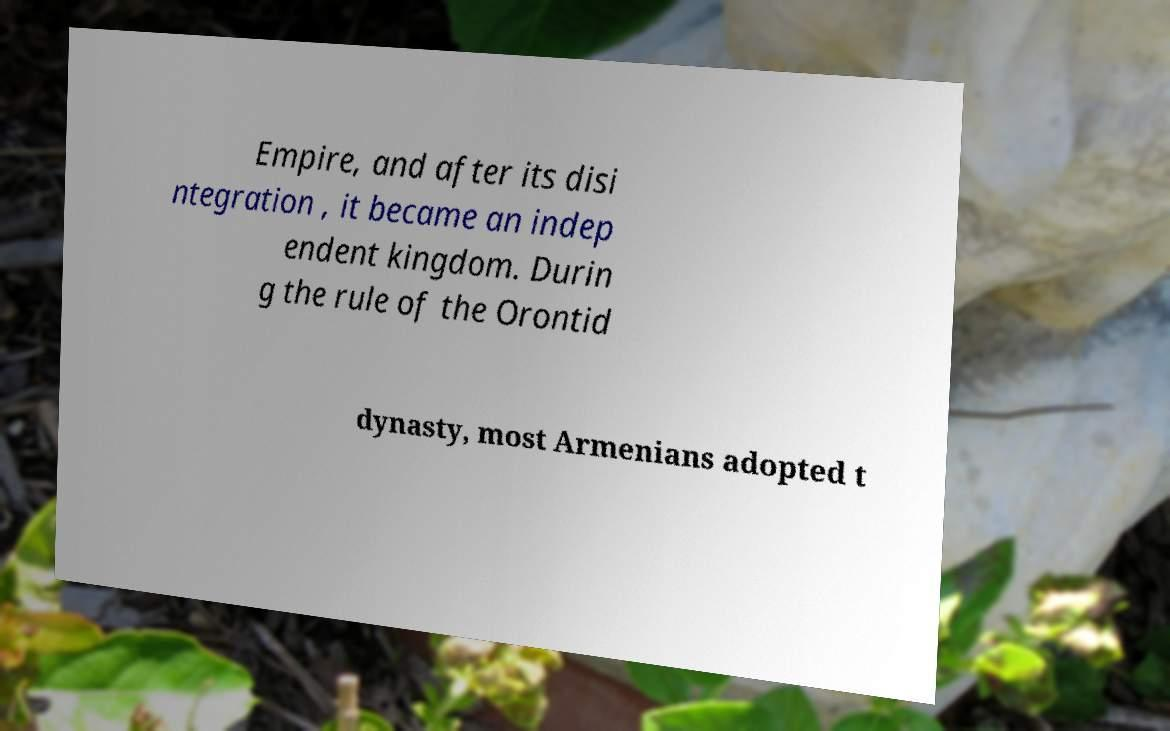What messages or text are displayed in this image? I need them in a readable, typed format. Empire, and after its disi ntegration , it became an indep endent kingdom. Durin g the rule of the Orontid dynasty, most Armenians adopted t 